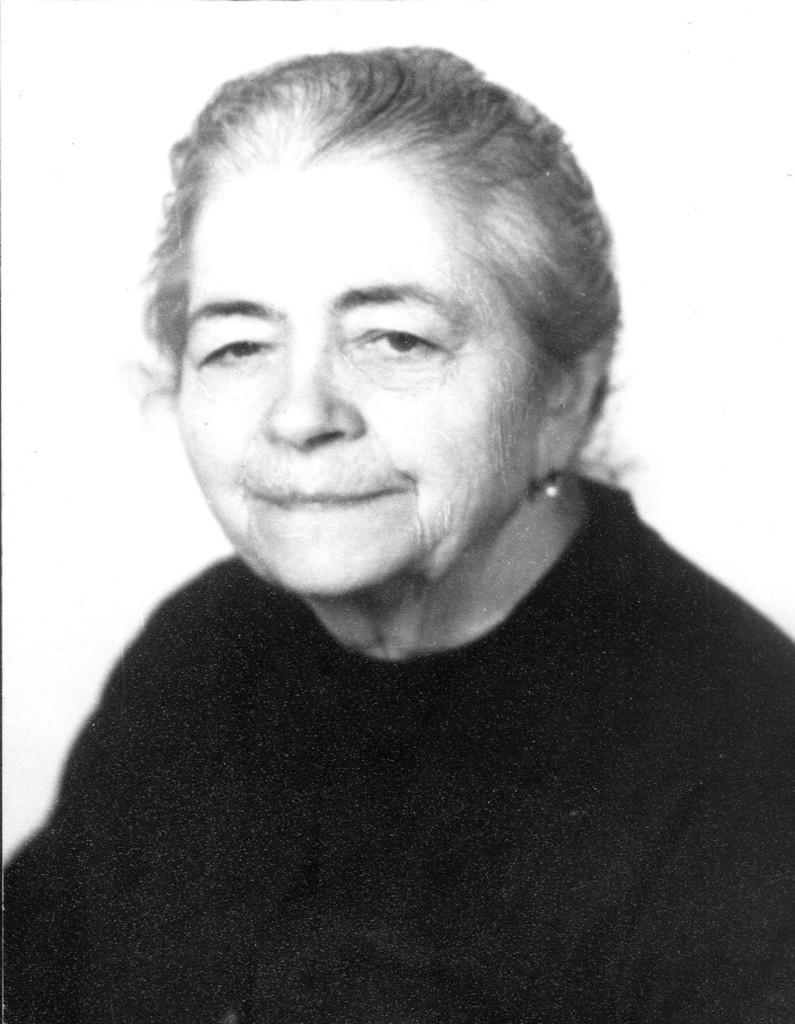What is the color scheme of the image? The image is black and white. Who is present in the image? There is a woman in the image. What is the woman wearing? The woman is wearing a black dress. What is the woman doing in the image? The woman is looking at a picture. What is the background of the image? The background of the image is white. What type of lead can be seen in the image? There is no lead present in the image. Is there a stove visible in the image? No, there is no stove visible in the image. 